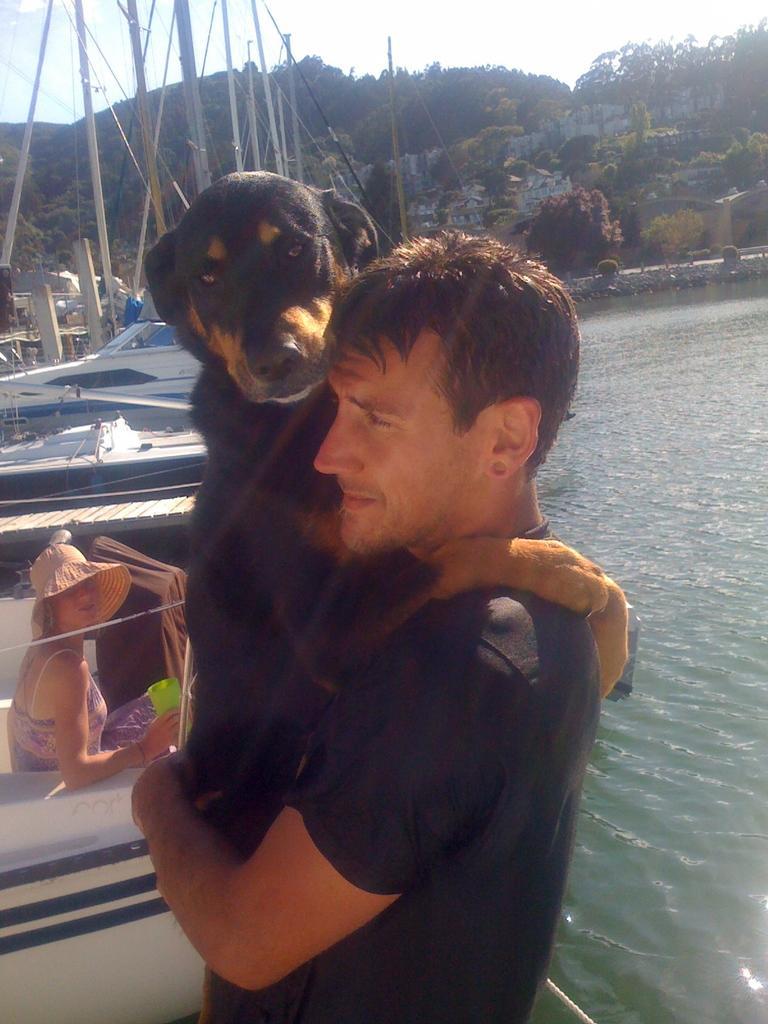Could you give a brief overview of what you see in this image? In this picture we can see group of people, in the middle of the image we can see a man holding his dog in his hands, and we can see water, couple of boats, couple of buildings and couple of trees. 